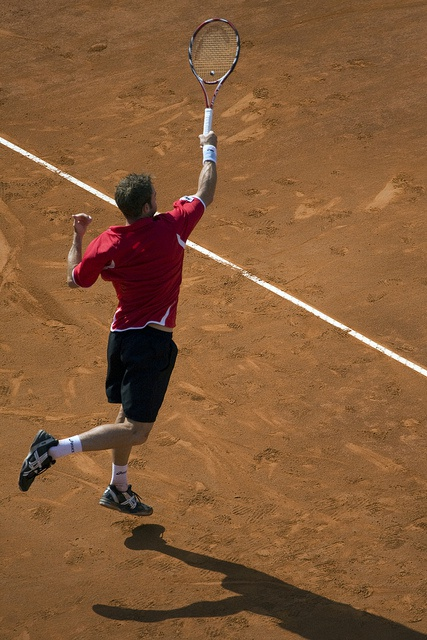Describe the objects in this image and their specific colors. I can see people in brown, black, maroon, and gray tones and tennis racket in brown, gray, and tan tones in this image. 